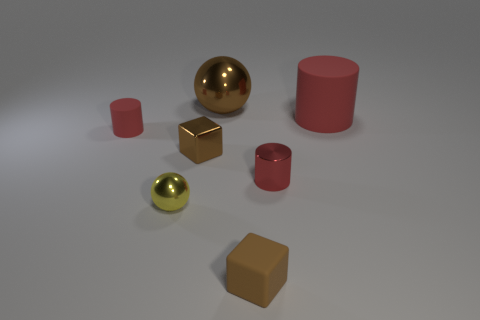Add 3 big purple cubes. How many objects exist? 10 Subtract all blocks. How many objects are left? 5 Subtract all yellow spheres. How many spheres are left? 1 Subtract all tiny metallic cylinders. How many cylinders are left? 2 Subtract 1 cylinders. How many cylinders are left? 2 Subtract all yellow cubes. How many yellow spheres are left? 1 Subtract all big red shiny objects. Subtract all red metallic cylinders. How many objects are left? 6 Add 7 small brown metal blocks. How many small brown metal blocks are left? 8 Add 5 brown shiny blocks. How many brown shiny blocks exist? 6 Subtract 1 brown blocks. How many objects are left? 6 